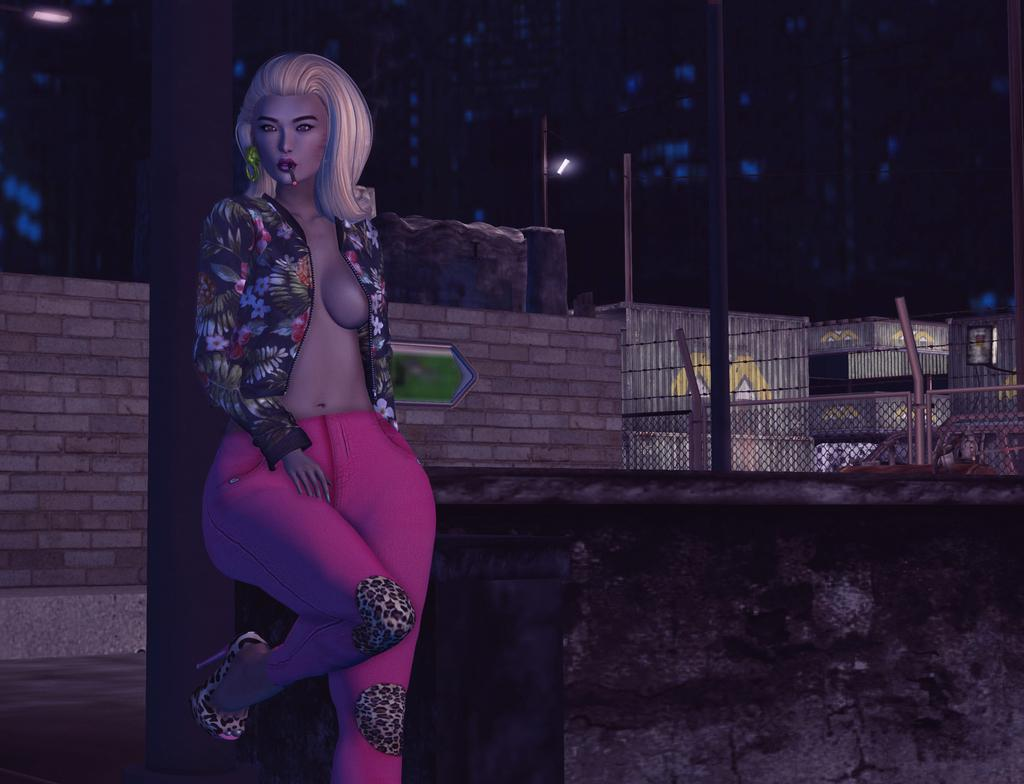What is the main subject in the image? There is a mannequin in the image. What can be seen behind the mannequin? There is a wall in the image. What type of barrier is present in the image? There is fencing in the image. What structure is visible in the background? There is a building in the background of the image. What is the source of light in the image? There is a street light in the image. What type of flame can be seen on the mannequin in the image? There is no flame present on the mannequin or anywhere in the image. 